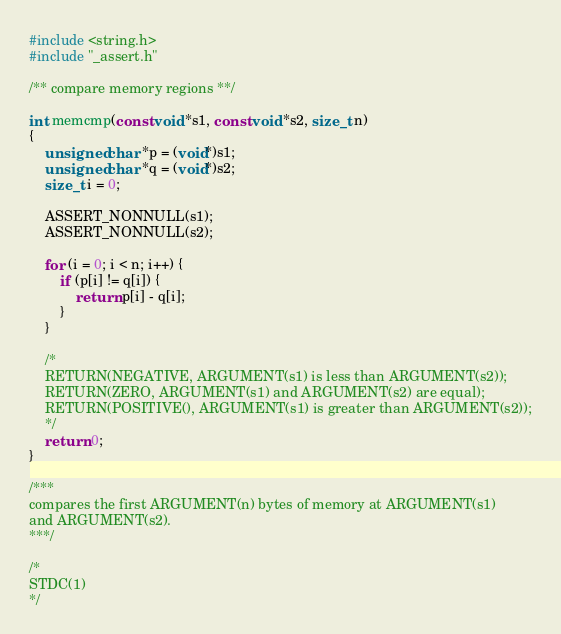Convert code to text. <code><loc_0><loc_0><loc_500><loc_500><_C_>#include <string.h>
#include "_assert.h"

/** compare memory regions **/

int memcmp(const void *s1, const void *s2, size_t n)
{
	unsigned char *p = (void*)s1;
	unsigned char *q = (void*)s2;
	size_t i = 0;

	ASSERT_NONNULL(s1);
	ASSERT_NONNULL(s2);

	for (i = 0; i < n; i++) {
		if (p[i] != q[i]) {
			return p[i] - q[i];
		}
	}

	/*
	RETURN(NEGATIVE, ARGUMENT(s1) is less than ARGUMENT(s2));
	RETURN(ZERO, ARGUMENT(s1) and ARGUMENT(s2) are equal);
	RETURN(POSITIVE(), ARGUMENT(s1) is greater than ARGUMENT(s2));
	*/
	return 0;
}

/***
compares the first ARGUMENT(n) bytes of memory at ARGUMENT(s1)
and ARGUMENT(s2).
***/

/*
STDC(1)
*/
</code> 